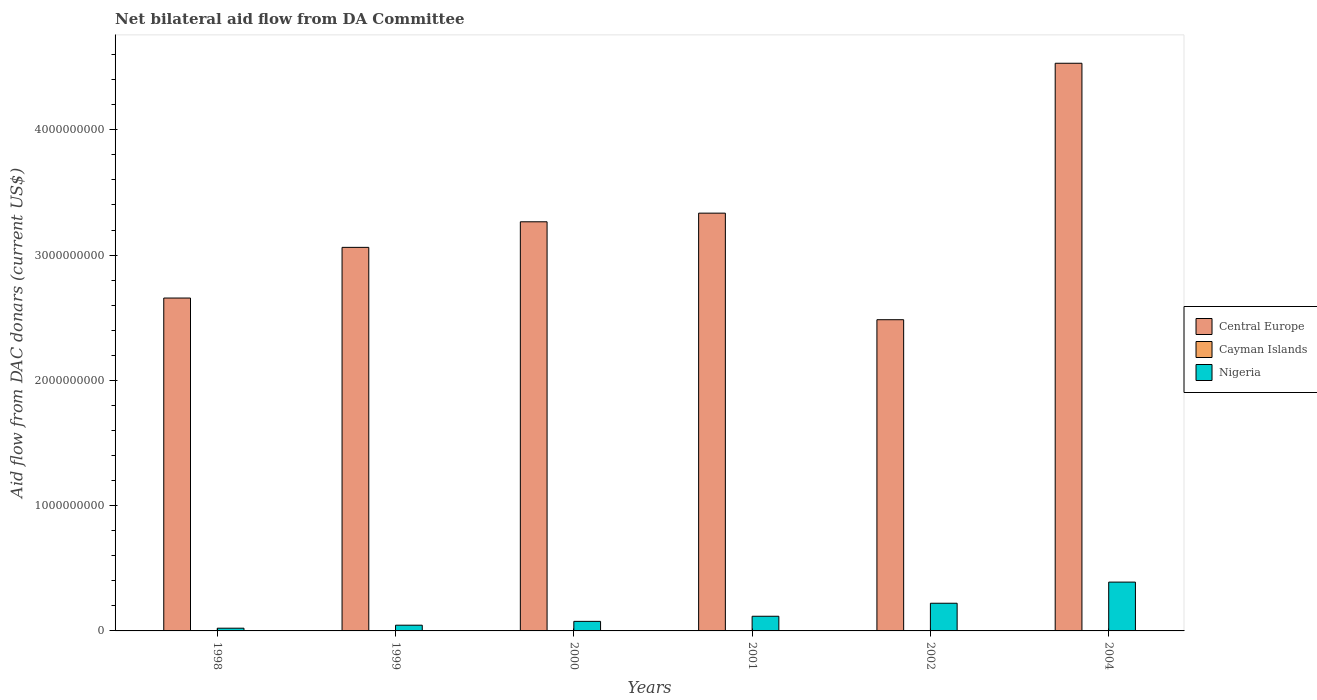How many groups of bars are there?
Provide a succinct answer. 6. Are the number of bars per tick equal to the number of legend labels?
Provide a short and direct response. No. Are the number of bars on each tick of the X-axis equal?
Provide a short and direct response. No. In how many cases, is the number of bars for a given year not equal to the number of legend labels?
Offer a very short reply. 4. What is the aid flow in in Nigeria in 2002?
Offer a terse response. 2.21e+08. Across all years, what is the maximum aid flow in in Nigeria?
Keep it short and to the point. 3.90e+08. Across all years, what is the minimum aid flow in in Central Europe?
Keep it short and to the point. 2.48e+09. What is the total aid flow in in Cayman Islands in the graph?
Ensure brevity in your answer.  3.52e+06. What is the difference between the aid flow in in Central Europe in 1998 and that in 1999?
Make the answer very short. -4.04e+08. What is the difference between the aid flow in in Central Europe in 2000 and the aid flow in in Cayman Islands in 1998?
Make the answer very short. 3.27e+09. What is the average aid flow in in Central Europe per year?
Your answer should be very brief. 3.22e+09. In the year 1999, what is the difference between the aid flow in in Cayman Islands and aid flow in in Central Europe?
Your answer should be compact. -3.06e+09. What is the ratio of the aid flow in in Central Europe in 2000 to that in 2002?
Give a very brief answer. 1.31. What is the difference between the highest and the second highest aid flow in in Central Europe?
Provide a short and direct response. 1.20e+09. What is the difference between the highest and the lowest aid flow in in Nigeria?
Make the answer very short. 3.68e+08. In how many years, is the aid flow in in Nigeria greater than the average aid flow in in Nigeria taken over all years?
Ensure brevity in your answer.  2. Is the sum of the aid flow in in Central Europe in 2002 and 2004 greater than the maximum aid flow in in Cayman Islands across all years?
Your answer should be very brief. Yes. Is it the case that in every year, the sum of the aid flow in in Central Europe and aid flow in in Nigeria is greater than the aid flow in in Cayman Islands?
Keep it short and to the point. Yes. How many years are there in the graph?
Offer a very short reply. 6. What is the difference between two consecutive major ticks on the Y-axis?
Your answer should be compact. 1.00e+09. Where does the legend appear in the graph?
Offer a terse response. Center right. How many legend labels are there?
Keep it short and to the point. 3. How are the legend labels stacked?
Provide a short and direct response. Vertical. What is the title of the graph?
Provide a succinct answer. Net bilateral aid flow from DA Committee. What is the label or title of the Y-axis?
Provide a short and direct response. Aid flow from DAC donars (current US$). What is the Aid flow from DAC donars (current US$) in Central Europe in 1998?
Offer a very short reply. 2.66e+09. What is the Aid flow from DAC donars (current US$) in Nigeria in 1998?
Provide a short and direct response. 2.18e+07. What is the Aid flow from DAC donars (current US$) in Central Europe in 1999?
Keep it short and to the point. 3.06e+09. What is the Aid flow from DAC donars (current US$) of Cayman Islands in 1999?
Offer a terse response. 3.29e+06. What is the Aid flow from DAC donars (current US$) in Nigeria in 1999?
Offer a very short reply. 4.58e+07. What is the Aid flow from DAC donars (current US$) of Central Europe in 2000?
Provide a succinct answer. 3.27e+09. What is the Aid flow from DAC donars (current US$) of Cayman Islands in 2000?
Offer a very short reply. 0. What is the Aid flow from DAC donars (current US$) in Nigeria in 2000?
Make the answer very short. 7.63e+07. What is the Aid flow from DAC donars (current US$) of Central Europe in 2001?
Provide a short and direct response. 3.33e+09. What is the Aid flow from DAC donars (current US$) in Nigeria in 2001?
Your answer should be very brief. 1.17e+08. What is the Aid flow from DAC donars (current US$) of Central Europe in 2002?
Offer a terse response. 2.48e+09. What is the Aid flow from DAC donars (current US$) of Cayman Islands in 2002?
Make the answer very short. 0. What is the Aid flow from DAC donars (current US$) of Nigeria in 2002?
Make the answer very short. 2.21e+08. What is the Aid flow from DAC donars (current US$) in Central Europe in 2004?
Keep it short and to the point. 4.53e+09. What is the Aid flow from DAC donars (current US$) of Cayman Islands in 2004?
Provide a short and direct response. 0. What is the Aid flow from DAC donars (current US$) of Nigeria in 2004?
Offer a terse response. 3.90e+08. Across all years, what is the maximum Aid flow from DAC donars (current US$) of Central Europe?
Ensure brevity in your answer.  4.53e+09. Across all years, what is the maximum Aid flow from DAC donars (current US$) of Cayman Islands?
Your response must be concise. 3.29e+06. Across all years, what is the maximum Aid flow from DAC donars (current US$) in Nigeria?
Ensure brevity in your answer.  3.90e+08. Across all years, what is the minimum Aid flow from DAC donars (current US$) of Central Europe?
Make the answer very short. 2.48e+09. Across all years, what is the minimum Aid flow from DAC donars (current US$) in Cayman Islands?
Give a very brief answer. 0. Across all years, what is the minimum Aid flow from DAC donars (current US$) of Nigeria?
Ensure brevity in your answer.  2.18e+07. What is the total Aid flow from DAC donars (current US$) of Central Europe in the graph?
Offer a very short reply. 1.93e+1. What is the total Aid flow from DAC donars (current US$) in Cayman Islands in the graph?
Give a very brief answer. 3.52e+06. What is the total Aid flow from DAC donars (current US$) in Nigeria in the graph?
Provide a succinct answer. 8.72e+08. What is the difference between the Aid flow from DAC donars (current US$) in Central Europe in 1998 and that in 1999?
Keep it short and to the point. -4.04e+08. What is the difference between the Aid flow from DAC donars (current US$) of Cayman Islands in 1998 and that in 1999?
Provide a short and direct response. -3.06e+06. What is the difference between the Aid flow from DAC donars (current US$) in Nigeria in 1998 and that in 1999?
Make the answer very short. -2.39e+07. What is the difference between the Aid flow from DAC donars (current US$) of Central Europe in 1998 and that in 2000?
Give a very brief answer. -6.09e+08. What is the difference between the Aid flow from DAC donars (current US$) of Nigeria in 1998 and that in 2000?
Your answer should be very brief. -5.45e+07. What is the difference between the Aid flow from DAC donars (current US$) of Central Europe in 1998 and that in 2001?
Give a very brief answer. -6.78e+08. What is the difference between the Aid flow from DAC donars (current US$) of Nigeria in 1998 and that in 2001?
Offer a very short reply. -9.53e+07. What is the difference between the Aid flow from DAC donars (current US$) in Central Europe in 1998 and that in 2002?
Offer a terse response. 1.73e+08. What is the difference between the Aid flow from DAC donars (current US$) in Nigeria in 1998 and that in 2002?
Provide a succinct answer. -1.99e+08. What is the difference between the Aid flow from DAC donars (current US$) in Central Europe in 1998 and that in 2004?
Make the answer very short. -1.87e+09. What is the difference between the Aid flow from DAC donars (current US$) of Nigeria in 1998 and that in 2004?
Make the answer very short. -3.68e+08. What is the difference between the Aid flow from DAC donars (current US$) of Central Europe in 1999 and that in 2000?
Keep it short and to the point. -2.04e+08. What is the difference between the Aid flow from DAC donars (current US$) in Nigeria in 1999 and that in 2000?
Your response must be concise. -3.05e+07. What is the difference between the Aid flow from DAC donars (current US$) of Central Europe in 1999 and that in 2001?
Ensure brevity in your answer.  -2.73e+08. What is the difference between the Aid flow from DAC donars (current US$) of Nigeria in 1999 and that in 2001?
Your answer should be compact. -7.13e+07. What is the difference between the Aid flow from DAC donars (current US$) in Central Europe in 1999 and that in 2002?
Your answer should be compact. 5.77e+08. What is the difference between the Aid flow from DAC donars (current US$) of Nigeria in 1999 and that in 2002?
Your response must be concise. -1.75e+08. What is the difference between the Aid flow from DAC donars (current US$) of Central Europe in 1999 and that in 2004?
Your answer should be compact. -1.47e+09. What is the difference between the Aid flow from DAC donars (current US$) of Nigeria in 1999 and that in 2004?
Keep it short and to the point. -3.44e+08. What is the difference between the Aid flow from DAC donars (current US$) in Central Europe in 2000 and that in 2001?
Ensure brevity in your answer.  -6.89e+07. What is the difference between the Aid flow from DAC donars (current US$) in Nigeria in 2000 and that in 2001?
Provide a succinct answer. -4.08e+07. What is the difference between the Aid flow from DAC donars (current US$) in Central Europe in 2000 and that in 2002?
Offer a terse response. 7.82e+08. What is the difference between the Aid flow from DAC donars (current US$) in Nigeria in 2000 and that in 2002?
Offer a very short reply. -1.45e+08. What is the difference between the Aid flow from DAC donars (current US$) of Central Europe in 2000 and that in 2004?
Your answer should be compact. -1.27e+09. What is the difference between the Aid flow from DAC donars (current US$) in Nigeria in 2000 and that in 2004?
Your answer should be compact. -3.13e+08. What is the difference between the Aid flow from DAC donars (current US$) in Central Europe in 2001 and that in 2002?
Offer a terse response. 8.51e+08. What is the difference between the Aid flow from DAC donars (current US$) in Nigeria in 2001 and that in 2002?
Your answer should be compact. -1.04e+08. What is the difference between the Aid flow from DAC donars (current US$) in Central Europe in 2001 and that in 2004?
Your response must be concise. -1.20e+09. What is the difference between the Aid flow from DAC donars (current US$) of Nigeria in 2001 and that in 2004?
Your answer should be compact. -2.73e+08. What is the difference between the Aid flow from DAC donars (current US$) in Central Europe in 2002 and that in 2004?
Your response must be concise. -2.05e+09. What is the difference between the Aid flow from DAC donars (current US$) in Nigeria in 2002 and that in 2004?
Provide a succinct answer. -1.69e+08. What is the difference between the Aid flow from DAC donars (current US$) of Central Europe in 1998 and the Aid flow from DAC donars (current US$) of Cayman Islands in 1999?
Your response must be concise. 2.65e+09. What is the difference between the Aid flow from DAC donars (current US$) in Central Europe in 1998 and the Aid flow from DAC donars (current US$) in Nigeria in 1999?
Provide a short and direct response. 2.61e+09. What is the difference between the Aid flow from DAC donars (current US$) in Cayman Islands in 1998 and the Aid flow from DAC donars (current US$) in Nigeria in 1999?
Offer a very short reply. -4.55e+07. What is the difference between the Aid flow from DAC donars (current US$) in Central Europe in 1998 and the Aid flow from DAC donars (current US$) in Nigeria in 2000?
Give a very brief answer. 2.58e+09. What is the difference between the Aid flow from DAC donars (current US$) in Cayman Islands in 1998 and the Aid flow from DAC donars (current US$) in Nigeria in 2000?
Your response must be concise. -7.60e+07. What is the difference between the Aid flow from DAC donars (current US$) in Central Europe in 1998 and the Aid flow from DAC donars (current US$) in Nigeria in 2001?
Offer a very short reply. 2.54e+09. What is the difference between the Aid flow from DAC donars (current US$) in Cayman Islands in 1998 and the Aid flow from DAC donars (current US$) in Nigeria in 2001?
Provide a succinct answer. -1.17e+08. What is the difference between the Aid flow from DAC donars (current US$) in Central Europe in 1998 and the Aid flow from DAC donars (current US$) in Nigeria in 2002?
Ensure brevity in your answer.  2.44e+09. What is the difference between the Aid flow from DAC donars (current US$) of Cayman Islands in 1998 and the Aid flow from DAC donars (current US$) of Nigeria in 2002?
Offer a terse response. -2.21e+08. What is the difference between the Aid flow from DAC donars (current US$) of Central Europe in 1998 and the Aid flow from DAC donars (current US$) of Nigeria in 2004?
Ensure brevity in your answer.  2.27e+09. What is the difference between the Aid flow from DAC donars (current US$) of Cayman Islands in 1998 and the Aid flow from DAC donars (current US$) of Nigeria in 2004?
Offer a very short reply. -3.89e+08. What is the difference between the Aid flow from DAC donars (current US$) of Central Europe in 1999 and the Aid flow from DAC donars (current US$) of Nigeria in 2000?
Make the answer very short. 2.99e+09. What is the difference between the Aid flow from DAC donars (current US$) of Cayman Islands in 1999 and the Aid flow from DAC donars (current US$) of Nigeria in 2000?
Make the answer very short. -7.30e+07. What is the difference between the Aid flow from DAC donars (current US$) in Central Europe in 1999 and the Aid flow from DAC donars (current US$) in Nigeria in 2001?
Offer a terse response. 2.94e+09. What is the difference between the Aid flow from DAC donars (current US$) in Cayman Islands in 1999 and the Aid flow from DAC donars (current US$) in Nigeria in 2001?
Offer a terse response. -1.14e+08. What is the difference between the Aid flow from DAC donars (current US$) of Central Europe in 1999 and the Aid flow from DAC donars (current US$) of Nigeria in 2002?
Provide a short and direct response. 2.84e+09. What is the difference between the Aid flow from DAC donars (current US$) of Cayman Islands in 1999 and the Aid flow from DAC donars (current US$) of Nigeria in 2002?
Make the answer very short. -2.18e+08. What is the difference between the Aid flow from DAC donars (current US$) in Central Europe in 1999 and the Aid flow from DAC donars (current US$) in Nigeria in 2004?
Provide a short and direct response. 2.67e+09. What is the difference between the Aid flow from DAC donars (current US$) of Cayman Islands in 1999 and the Aid flow from DAC donars (current US$) of Nigeria in 2004?
Your answer should be compact. -3.86e+08. What is the difference between the Aid flow from DAC donars (current US$) in Central Europe in 2000 and the Aid flow from DAC donars (current US$) in Nigeria in 2001?
Give a very brief answer. 3.15e+09. What is the difference between the Aid flow from DAC donars (current US$) in Central Europe in 2000 and the Aid flow from DAC donars (current US$) in Nigeria in 2002?
Your answer should be very brief. 3.04e+09. What is the difference between the Aid flow from DAC donars (current US$) of Central Europe in 2000 and the Aid flow from DAC donars (current US$) of Nigeria in 2004?
Your response must be concise. 2.88e+09. What is the difference between the Aid flow from DAC donars (current US$) in Central Europe in 2001 and the Aid flow from DAC donars (current US$) in Nigeria in 2002?
Offer a very short reply. 3.11e+09. What is the difference between the Aid flow from DAC donars (current US$) of Central Europe in 2001 and the Aid flow from DAC donars (current US$) of Nigeria in 2004?
Your answer should be compact. 2.94e+09. What is the difference between the Aid flow from DAC donars (current US$) of Central Europe in 2002 and the Aid flow from DAC donars (current US$) of Nigeria in 2004?
Ensure brevity in your answer.  2.09e+09. What is the average Aid flow from DAC donars (current US$) in Central Europe per year?
Your response must be concise. 3.22e+09. What is the average Aid flow from DAC donars (current US$) of Cayman Islands per year?
Your answer should be compact. 5.87e+05. What is the average Aid flow from DAC donars (current US$) of Nigeria per year?
Provide a short and direct response. 1.45e+08. In the year 1998, what is the difference between the Aid flow from DAC donars (current US$) in Central Europe and Aid flow from DAC donars (current US$) in Cayman Islands?
Ensure brevity in your answer.  2.66e+09. In the year 1998, what is the difference between the Aid flow from DAC donars (current US$) in Central Europe and Aid flow from DAC donars (current US$) in Nigeria?
Keep it short and to the point. 2.64e+09. In the year 1998, what is the difference between the Aid flow from DAC donars (current US$) in Cayman Islands and Aid flow from DAC donars (current US$) in Nigeria?
Ensure brevity in your answer.  -2.16e+07. In the year 1999, what is the difference between the Aid flow from DAC donars (current US$) in Central Europe and Aid flow from DAC donars (current US$) in Cayman Islands?
Offer a very short reply. 3.06e+09. In the year 1999, what is the difference between the Aid flow from DAC donars (current US$) of Central Europe and Aid flow from DAC donars (current US$) of Nigeria?
Your answer should be very brief. 3.02e+09. In the year 1999, what is the difference between the Aid flow from DAC donars (current US$) of Cayman Islands and Aid flow from DAC donars (current US$) of Nigeria?
Offer a terse response. -4.25e+07. In the year 2000, what is the difference between the Aid flow from DAC donars (current US$) in Central Europe and Aid flow from DAC donars (current US$) in Nigeria?
Make the answer very short. 3.19e+09. In the year 2001, what is the difference between the Aid flow from DAC donars (current US$) in Central Europe and Aid flow from DAC donars (current US$) in Nigeria?
Ensure brevity in your answer.  3.22e+09. In the year 2002, what is the difference between the Aid flow from DAC donars (current US$) of Central Europe and Aid flow from DAC donars (current US$) of Nigeria?
Give a very brief answer. 2.26e+09. In the year 2004, what is the difference between the Aid flow from DAC donars (current US$) in Central Europe and Aid flow from DAC donars (current US$) in Nigeria?
Your answer should be very brief. 4.14e+09. What is the ratio of the Aid flow from DAC donars (current US$) in Central Europe in 1998 to that in 1999?
Your response must be concise. 0.87. What is the ratio of the Aid flow from DAC donars (current US$) of Cayman Islands in 1998 to that in 1999?
Your answer should be very brief. 0.07. What is the ratio of the Aid flow from DAC donars (current US$) in Nigeria in 1998 to that in 1999?
Ensure brevity in your answer.  0.48. What is the ratio of the Aid flow from DAC donars (current US$) of Central Europe in 1998 to that in 2000?
Offer a very short reply. 0.81. What is the ratio of the Aid flow from DAC donars (current US$) in Nigeria in 1998 to that in 2000?
Ensure brevity in your answer.  0.29. What is the ratio of the Aid flow from DAC donars (current US$) in Central Europe in 1998 to that in 2001?
Make the answer very short. 0.8. What is the ratio of the Aid flow from DAC donars (current US$) in Nigeria in 1998 to that in 2001?
Make the answer very short. 0.19. What is the ratio of the Aid flow from DAC donars (current US$) of Central Europe in 1998 to that in 2002?
Make the answer very short. 1.07. What is the ratio of the Aid flow from DAC donars (current US$) of Nigeria in 1998 to that in 2002?
Provide a short and direct response. 0.1. What is the ratio of the Aid flow from DAC donars (current US$) of Central Europe in 1998 to that in 2004?
Your answer should be very brief. 0.59. What is the ratio of the Aid flow from DAC donars (current US$) in Nigeria in 1998 to that in 2004?
Provide a short and direct response. 0.06. What is the ratio of the Aid flow from DAC donars (current US$) in Central Europe in 1999 to that in 2000?
Give a very brief answer. 0.94. What is the ratio of the Aid flow from DAC donars (current US$) in Nigeria in 1999 to that in 2000?
Give a very brief answer. 0.6. What is the ratio of the Aid flow from DAC donars (current US$) in Central Europe in 1999 to that in 2001?
Give a very brief answer. 0.92. What is the ratio of the Aid flow from DAC donars (current US$) of Nigeria in 1999 to that in 2001?
Your response must be concise. 0.39. What is the ratio of the Aid flow from DAC donars (current US$) in Central Europe in 1999 to that in 2002?
Offer a very short reply. 1.23. What is the ratio of the Aid flow from DAC donars (current US$) in Nigeria in 1999 to that in 2002?
Make the answer very short. 0.21. What is the ratio of the Aid flow from DAC donars (current US$) in Central Europe in 1999 to that in 2004?
Offer a terse response. 0.68. What is the ratio of the Aid flow from DAC donars (current US$) of Nigeria in 1999 to that in 2004?
Your answer should be very brief. 0.12. What is the ratio of the Aid flow from DAC donars (current US$) of Central Europe in 2000 to that in 2001?
Your answer should be compact. 0.98. What is the ratio of the Aid flow from DAC donars (current US$) of Nigeria in 2000 to that in 2001?
Your answer should be very brief. 0.65. What is the ratio of the Aid flow from DAC donars (current US$) in Central Europe in 2000 to that in 2002?
Offer a very short reply. 1.31. What is the ratio of the Aid flow from DAC donars (current US$) of Nigeria in 2000 to that in 2002?
Give a very brief answer. 0.35. What is the ratio of the Aid flow from DAC donars (current US$) of Central Europe in 2000 to that in 2004?
Your response must be concise. 0.72. What is the ratio of the Aid flow from DAC donars (current US$) in Nigeria in 2000 to that in 2004?
Make the answer very short. 0.2. What is the ratio of the Aid flow from DAC donars (current US$) in Central Europe in 2001 to that in 2002?
Keep it short and to the point. 1.34. What is the ratio of the Aid flow from DAC donars (current US$) in Nigeria in 2001 to that in 2002?
Make the answer very short. 0.53. What is the ratio of the Aid flow from DAC donars (current US$) in Central Europe in 2001 to that in 2004?
Provide a succinct answer. 0.74. What is the ratio of the Aid flow from DAC donars (current US$) in Nigeria in 2001 to that in 2004?
Your response must be concise. 0.3. What is the ratio of the Aid flow from DAC donars (current US$) of Central Europe in 2002 to that in 2004?
Provide a succinct answer. 0.55. What is the ratio of the Aid flow from DAC donars (current US$) of Nigeria in 2002 to that in 2004?
Offer a terse response. 0.57. What is the difference between the highest and the second highest Aid flow from DAC donars (current US$) in Central Europe?
Offer a very short reply. 1.20e+09. What is the difference between the highest and the second highest Aid flow from DAC donars (current US$) of Nigeria?
Give a very brief answer. 1.69e+08. What is the difference between the highest and the lowest Aid flow from DAC donars (current US$) in Central Europe?
Your answer should be compact. 2.05e+09. What is the difference between the highest and the lowest Aid flow from DAC donars (current US$) in Cayman Islands?
Offer a very short reply. 3.29e+06. What is the difference between the highest and the lowest Aid flow from DAC donars (current US$) in Nigeria?
Provide a short and direct response. 3.68e+08. 